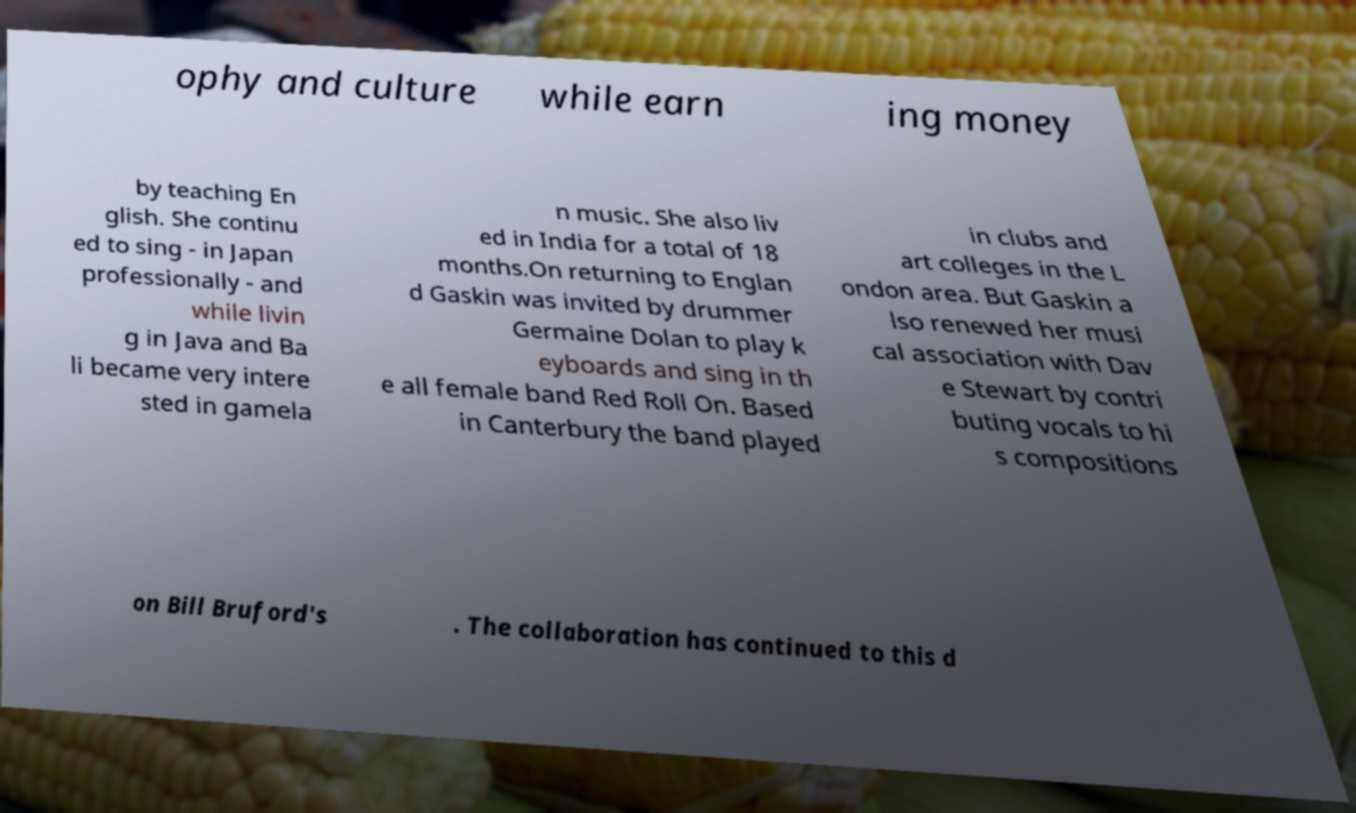Can you accurately transcribe the text from the provided image for me? ophy and culture while earn ing money by teaching En glish. She continu ed to sing - in Japan professionally - and while livin g in Java and Ba li became very intere sted in gamela n music. She also liv ed in India for a total of 18 months.On returning to Englan d Gaskin was invited by drummer Germaine Dolan to play k eyboards and sing in th e all female band Red Roll On. Based in Canterbury the band played in clubs and art colleges in the L ondon area. But Gaskin a lso renewed her musi cal association with Dav e Stewart by contri buting vocals to hi s compositions on Bill Bruford's . The collaboration has continued to this d 